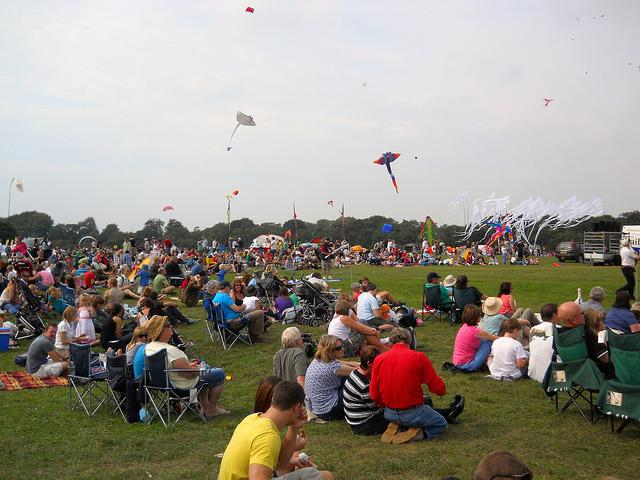What type toys unite these people today?

Choices:
A) trucks
B) chairs
C) toys
D) drones toys 